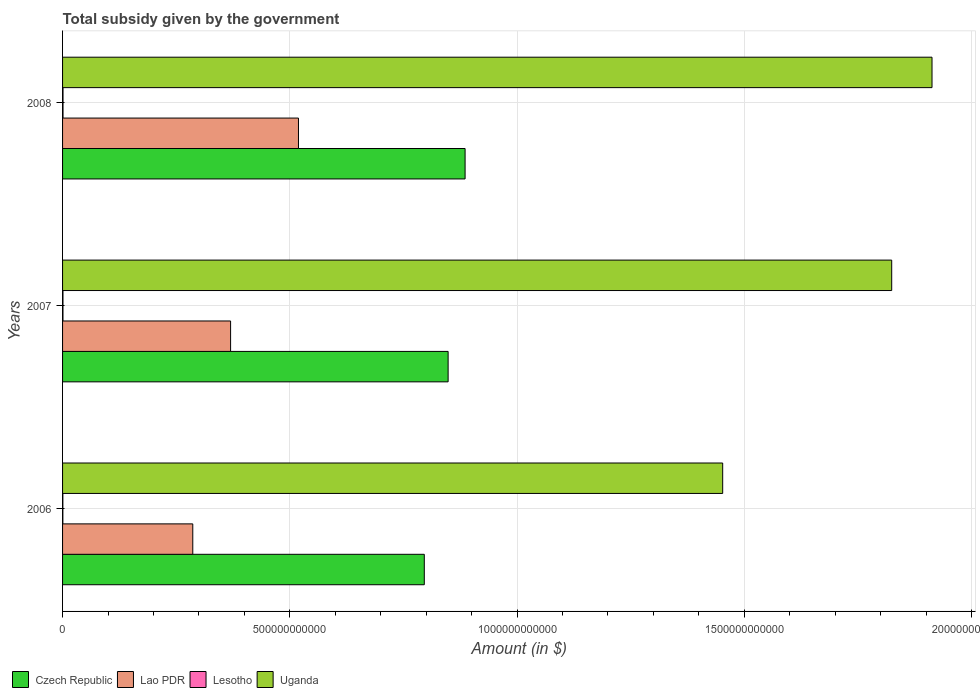How many different coloured bars are there?
Your response must be concise. 4. Are the number of bars per tick equal to the number of legend labels?
Give a very brief answer. Yes. Are the number of bars on each tick of the Y-axis equal?
Your response must be concise. Yes. How many bars are there on the 3rd tick from the top?
Provide a short and direct response. 4. What is the label of the 3rd group of bars from the top?
Your response must be concise. 2006. What is the total revenue collected by the government in Lao PDR in 2006?
Your answer should be very brief. 2.87e+11. Across all years, what is the maximum total revenue collected by the government in Uganda?
Your answer should be very brief. 1.91e+12. Across all years, what is the minimum total revenue collected by the government in Lao PDR?
Keep it short and to the point. 2.87e+11. In which year was the total revenue collected by the government in Czech Republic maximum?
Make the answer very short. 2008. In which year was the total revenue collected by the government in Lao PDR minimum?
Ensure brevity in your answer.  2006. What is the total total revenue collected by the government in Uganda in the graph?
Give a very brief answer. 5.19e+12. What is the difference between the total revenue collected by the government in Lao PDR in 2006 and that in 2008?
Give a very brief answer. -2.33e+11. What is the difference between the total revenue collected by the government in Lesotho in 2008 and the total revenue collected by the government in Czech Republic in 2007?
Give a very brief answer. -8.47e+11. What is the average total revenue collected by the government in Lao PDR per year?
Make the answer very short. 3.92e+11. In the year 2008, what is the difference between the total revenue collected by the government in Lesotho and total revenue collected by the government in Uganda?
Make the answer very short. -1.91e+12. What is the ratio of the total revenue collected by the government in Uganda in 2006 to that in 2008?
Keep it short and to the point. 0.76. Is the difference between the total revenue collected by the government in Lesotho in 2006 and 2008 greater than the difference between the total revenue collected by the government in Uganda in 2006 and 2008?
Give a very brief answer. Yes. What is the difference between the highest and the second highest total revenue collected by the government in Lesotho?
Keep it short and to the point. 8.93e+07. What is the difference between the highest and the lowest total revenue collected by the government in Czech Republic?
Give a very brief answer. 8.98e+1. Is it the case that in every year, the sum of the total revenue collected by the government in Lao PDR and total revenue collected by the government in Lesotho is greater than the sum of total revenue collected by the government in Czech Republic and total revenue collected by the government in Uganda?
Your answer should be very brief. No. What does the 4th bar from the top in 2008 represents?
Offer a very short reply. Czech Republic. What does the 4th bar from the bottom in 2008 represents?
Offer a very short reply. Uganda. How many bars are there?
Your answer should be compact. 12. What is the difference between two consecutive major ticks on the X-axis?
Make the answer very short. 5.00e+11. Does the graph contain grids?
Your answer should be compact. Yes. Where does the legend appear in the graph?
Offer a terse response. Bottom left. What is the title of the graph?
Ensure brevity in your answer.  Total subsidy given by the government. What is the label or title of the X-axis?
Keep it short and to the point. Amount (in $). What is the label or title of the Y-axis?
Your response must be concise. Years. What is the Amount (in $) of Czech Republic in 2006?
Offer a very short reply. 7.96e+11. What is the Amount (in $) of Lao PDR in 2006?
Provide a succinct answer. 2.87e+11. What is the Amount (in $) in Lesotho in 2006?
Give a very brief answer. 6.32e+08. What is the Amount (in $) of Uganda in 2006?
Your response must be concise. 1.45e+12. What is the Amount (in $) in Czech Republic in 2007?
Offer a terse response. 8.48e+11. What is the Amount (in $) in Lao PDR in 2007?
Provide a short and direct response. 3.70e+11. What is the Amount (in $) in Lesotho in 2007?
Offer a terse response. 8.93e+08. What is the Amount (in $) in Uganda in 2007?
Offer a terse response. 1.82e+12. What is the Amount (in $) in Czech Republic in 2008?
Offer a very short reply. 8.86e+11. What is the Amount (in $) in Lao PDR in 2008?
Your answer should be very brief. 5.19e+11. What is the Amount (in $) in Lesotho in 2008?
Your answer should be compact. 9.82e+08. What is the Amount (in $) of Uganda in 2008?
Ensure brevity in your answer.  1.91e+12. Across all years, what is the maximum Amount (in $) in Czech Republic?
Keep it short and to the point. 8.86e+11. Across all years, what is the maximum Amount (in $) in Lao PDR?
Provide a short and direct response. 5.19e+11. Across all years, what is the maximum Amount (in $) in Lesotho?
Keep it short and to the point. 9.82e+08. Across all years, what is the maximum Amount (in $) in Uganda?
Offer a terse response. 1.91e+12. Across all years, what is the minimum Amount (in $) in Czech Republic?
Provide a succinct answer. 7.96e+11. Across all years, what is the minimum Amount (in $) in Lao PDR?
Offer a terse response. 2.87e+11. Across all years, what is the minimum Amount (in $) in Lesotho?
Give a very brief answer. 6.32e+08. Across all years, what is the minimum Amount (in $) of Uganda?
Your answer should be compact. 1.45e+12. What is the total Amount (in $) of Czech Republic in the graph?
Ensure brevity in your answer.  2.53e+12. What is the total Amount (in $) of Lao PDR in the graph?
Provide a succinct answer. 1.18e+12. What is the total Amount (in $) in Lesotho in the graph?
Keep it short and to the point. 2.51e+09. What is the total Amount (in $) in Uganda in the graph?
Ensure brevity in your answer.  5.19e+12. What is the difference between the Amount (in $) in Czech Republic in 2006 and that in 2007?
Provide a short and direct response. -5.24e+1. What is the difference between the Amount (in $) in Lao PDR in 2006 and that in 2007?
Provide a short and direct response. -8.32e+1. What is the difference between the Amount (in $) in Lesotho in 2006 and that in 2007?
Your response must be concise. -2.61e+08. What is the difference between the Amount (in $) of Uganda in 2006 and that in 2007?
Offer a terse response. -3.72e+11. What is the difference between the Amount (in $) of Czech Republic in 2006 and that in 2008?
Your answer should be compact. -8.98e+1. What is the difference between the Amount (in $) of Lao PDR in 2006 and that in 2008?
Offer a terse response. -2.33e+11. What is the difference between the Amount (in $) in Lesotho in 2006 and that in 2008?
Your answer should be very brief. -3.50e+08. What is the difference between the Amount (in $) of Uganda in 2006 and that in 2008?
Your response must be concise. -4.61e+11. What is the difference between the Amount (in $) of Czech Republic in 2007 and that in 2008?
Offer a very short reply. -3.74e+1. What is the difference between the Amount (in $) in Lao PDR in 2007 and that in 2008?
Make the answer very short. -1.49e+11. What is the difference between the Amount (in $) in Lesotho in 2007 and that in 2008?
Offer a terse response. -8.93e+07. What is the difference between the Amount (in $) of Uganda in 2007 and that in 2008?
Provide a succinct answer. -8.87e+1. What is the difference between the Amount (in $) of Czech Republic in 2006 and the Amount (in $) of Lao PDR in 2007?
Make the answer very short. 4.26e+11. What is the difference between the Amount (in $) in Czech Republic in 2006 and the Amount (in $) in Lesotho in 2007?
Your answer should be compact. 7.95e+11. What is the difference between the Amount (in $) of Czech Republic in 2006 and the Amount (in $) of Uganda in 2007?
Provide a short and direct response. -1.03e+12. What is the difference between the Amount (in $) in Lao PDR in 2006 and the Amount (in $) in Lesotho in 2007?
Give a very brief answer. 2.86e+11. What is the difference between the Amount (in $) of Lao PDR in 2006 and the Amount (in $) of Uganda in 2007?
Your answer should be compact. -1.54e+12. What is the difference between the Amount (in $) of Lesotho in 2006 and the Amount (in $) of Uganda in 2007?
Provide a succinct answer. -1.82e+12. What is the difference between the Amount (in $) of Czech Republic in 2006 and the Amount (in $) of Lao PDR in 2008?
Provide a short and direct response. 2.77e+11. What is the difference between the Amount (in $) in Czech Republic in 2006 and the Amount (in $) in Lesotho in 2008?
Provide a short and direct response. 7.95e+11. What is the difference between the Amount (in $) in Czech Republic in 2006 and the Amount (in $) in Uganda in 2008?
Your response must be concise. -1.12e+12. What is the difference between the Amount (in $) in Lao PDR in 2006 and the Amount (in $) in Lesotho in 2008?
Your response must be concise. 2.86e+11. What is the difference between the Amount (in $) in Lao PDR in 2006 and the Amount (in $) in Uganda in 2008?
Ensure brevity in your answer.  -1.63e+12. What is the difference between the Amount (in $) in Lesotho in 2006 and the Amount (in $) in Uganda in 2008?
Offer a very short reply. -1.91e+12. What is the difference between the Amount (in $) in Czech Republic in 2007 and the Amount (in $) in Lao PDR in 2008?
Provide a short and direct response. 3.29e+11. What is the difference between the Amount (in $) in Czech Republic in 2007 and the Amount (in $) in Lesotho in 2008?
Ensure brevity in your answer.  8.47e+11. What is the difference between the Amount (in $) of Czech Republic in 2007 and the Amount (in $) of Uganda in 2008?
Ensure brevity in your answer.  -1.06e+12. What is the difference between the Amount (in $) in Lao PDR in 2007 and the Amount (in $) in Lesotho in 2008?
Your answer should be very brief. 3.69e+11. What is the difference between the Amount (in $) of Lao PDR in 2007 and the Amount (in $) of Uganda in 2008?
Offer a very short reply. -1.54e+12. What is the difference between the Amount (in $) of Lesotho in 2007 and the Amount (in $) of Uganda in 2008?
Your answer should be very brief. -1.91e+12. What is the average Amount (in $) in Czech Republic per year?
Offer a very short reply. 8.43e+11. What is the average Amount (in $) of Lao PDR per year?
Provide a succinct answer. 3.92e+11. What is the average Amount (in $) in Lesotho per year?
Give a very brief answer. 8.36e+08. What is the average Amount (in $) of Uganda per year?
Offer a very short reply. 1.73e+12. In the year 2006, what is the difference between the Amount (in $) in Czech Republic and Amount (in $) in Lao PDR?
Make the answer very short. 5.09e+11. In the year 2006, what is the difference between the Amount (in $) in Czech Republic and Amount (in $) in Lesotho?
Keep it short and to the point. 7.95e+11. In the year 2006, what is the difference between the Amount (in $) in Czech Republic and Amount (in $) in Uganda?
Keep it short and to the point. -6.57e+11. In the year 2006, what is the difference between the Amount (in $) in Lao PDR and Amount (in $) in Lesotho?
Your response must be concise. 2.86e+11. In the year 2006, what is the difference between the Amount (in $) of Lao PDR and Amount (in $) of Uganda?
Provide a succinct answer. -1.17e+12. In the year 2006, what is the difference between the Amount (in $) in Lesotho and Amount (in $) in Uganda?
Your response must be concise. -1.45e+12. In the year 2007, what is the difference between the Amount (in $) of Czech Republic and Amount (in $) of Lao PDR?
Your response must be concise. 4.79e+11. In the year 2007, what is the difference between the Amount (in $) of Czech Republic and Amount (in $) of Lesotho?
Provide a short and direct response. 8.48e+11. In the year 2007, what is the difference between the Amount (in $) in Czech Republic and Amount (in $) in Uganda?
Make the answer very short. -9.76e+11. In the year 2007, what is the difference between the Amount (in $) of Lao PDR and Amount (in $) of Lesotho?
Your answer should be very brief. 3.69e+11. In the year 2007, what is the difference between the Amount (in $) of Lao PDR and Amount (in $) of Uganda?
Your answer should be compact. -1.45e+12. In the year 2007, what is the difference between the Amount (in $) in Lesotho and Amount (in $) in Uganda?
Your answer should be very brief. -1.82e+12. In the year 2008, what is the difference between the Amount (in $) in Czech Republic and Amount (in $) in Lao PDR?
Make the answer very short. 3.67e+11. In the year 2008, what is the difference between the Amount (in $) of Czech Republic and Amount (in $) of Lesotho?
Provide a short and direct response. 8.85e+11. In the year 2008, what is the difference between the Amount (in $) in Czech Republic and Amount (in $) in Uganda?
Provide a succinct answer. -1.03e+12. In the year 2008, what is the difference between the Amount (in $) of Lao PDR and Amount (in $) of Lesotho?
Keep it short and to the point. 5.18e+11. In the year 2008, what is the difference between the Amount (in $) of Lao PDR and Amount (in $) of Uganda?
Keep it short and to the point. -1.39e+12. In the year 2008, what is the difference between the Amount (in $) of Lesotho and Amount (in $) of Uganda?
Provide a short and direct response. -1.91e+12. What is the ratio of the Amount (in $) of Czech Republic in 2006 to that in 2007?
Provide a succinct answer. 0.94. What is the ratio of the Amount (in $) in Lao PDR in 2006 to that in 2007?
Offer a very short reply. 0.78. What is the ratio of the Amount (in $) of Lesotho in 2006 to that in 2007?
Provide a succinct answer. 0.71. What is the ratio of the Amount (in $) in Uganda in 2006 to that in 2007?
Provide a short and direct response. 0.8. What is the ratio of the Amount (in $) in Czech Republic in 2006 to that in 2008?
Your answer should be compact. 0.9. What is the ratio of the Amount (in $) in Lao PDR in 2006 to that in 2008?
Provide a succinct answer. 0.55. What is the ratio of the Amount (in $) of Lesotho in 2006 to that in 2008?
Keep it short and to the point. 0.64. What is the ratio of the Amount (in $) in Uganda in 2006 to that in 2008?
Your answer should be compact. 0.76. What is the ratio of the Amount (in $) of Czech Republic in 2007 to that in 2008?
Give a very brief answer. 0.96. What is the ratio of the Amount (in $) in Lao PDR in 2007 to that in 2008?
Give a very brief answer. 0.71. What is the ratio of the Amount (in $) in Lesotho in 2007 to that in 2008?
Your answer should be very brief. 0.91. What is the ratio of the Amount (in $) in Uganda in 2007 to that in 2008?
Your answer should be very brief. 0.95. What is the difference between the highest and the second highest Amount (in $) in Czech Republic?
Your answer should be very brief. 3.74e+1. What is the difference between the highest and the second highest Amount (in $) of Lao PDR?
Your answer should be compact. 1.49e+11. What is the difference between the highest and the second highest Amount (in $) in Lesotho?
Offer a very short reply. 8.93e+07. What is the difference between the highest and the second highest Amount (in $) in Uganda?
Your answer should be compact. 8.87e+1. What is the difference between the highest and the lowest Amount (in $) of Czech Republic?
Offer a terse response. 8.98e+1. What is the difference between the highest and the lowest Amount (in $) of Lao PDR?
Give a very brief answer. 2.33e+11. What is the difference between the highest and the lowest Amount (in $) in Lesotho?
Your response must be concise. 3.50e+08. What is the difference between the highest and the lowest Amount (in $) in Uganda?
Ensure brevity in your answer.  4.61e+11. 